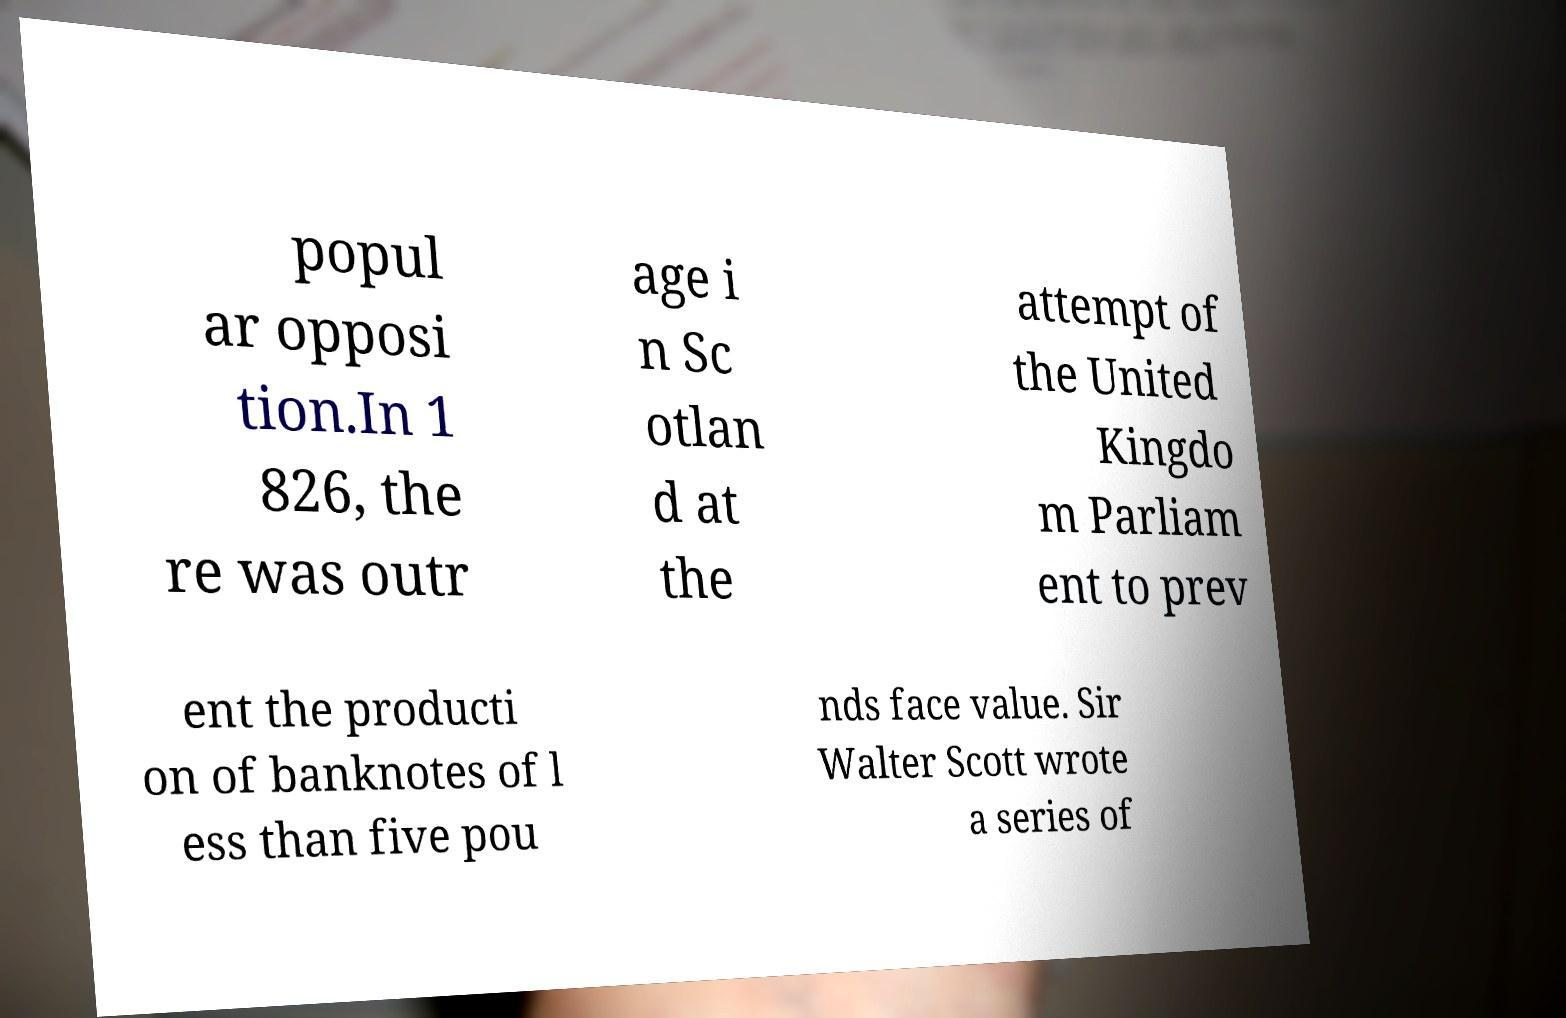Could you extract and type out the text from this image? popul ar opposi tion.In 1 826, the re was outr age i n Sc otlan d at the attempt of the United Kingdo m Parliam ent to prev ent the producti on of banknotes of l ess than five pou nds face value. Sir Walter Scott wrote a series of 